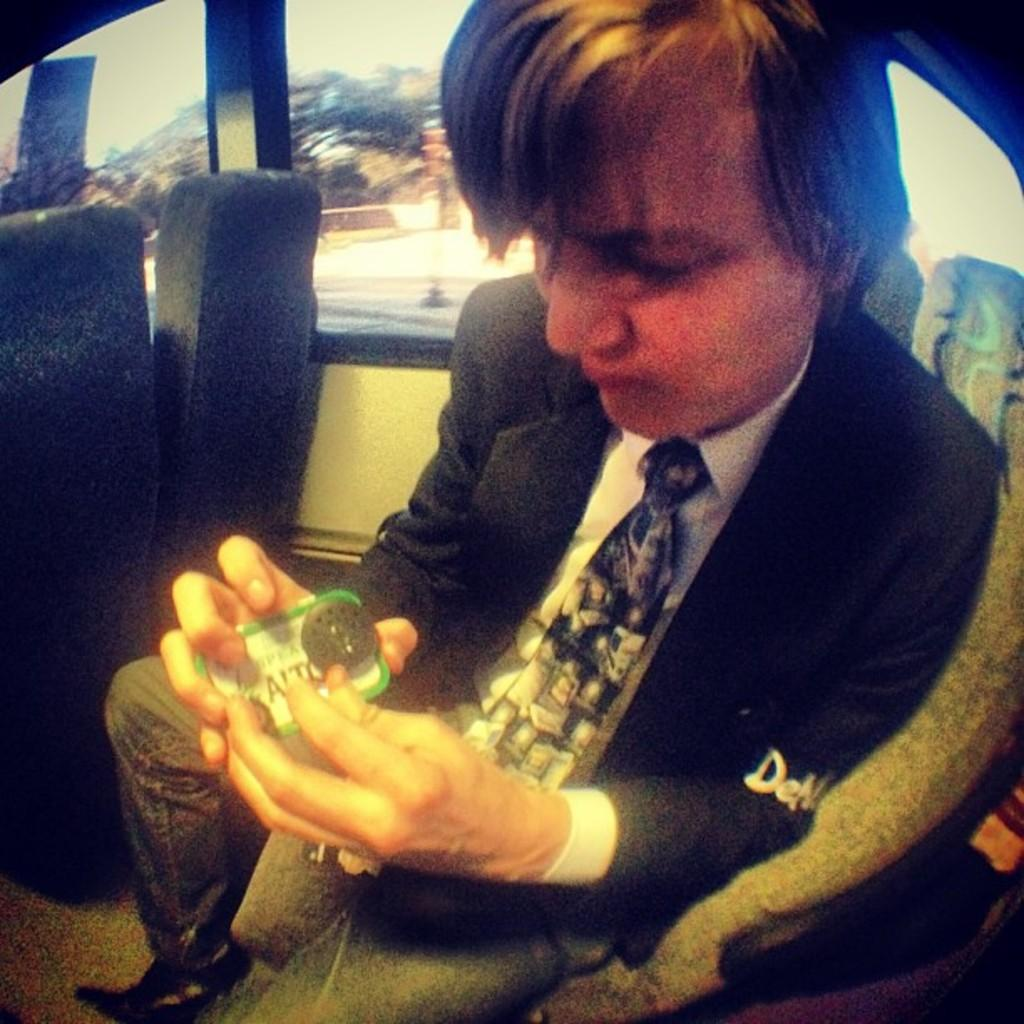Who is present in the image? There is a man in the image. What is the man wearing? The man is wearing a blazer and a tie. Where is the man located in the image? The man is sitting on a seat inside a vehicle. What is the man holding in the image? The man is holding an object with his hands. How many chairs are visible in the image? There are no chairs visible in the image; the man is sitting inside a vehicle. What type of pipe is the man smoking in the image? There is no pipe present in the image; the man is holding an object, but it is not specified as a pipe. 